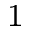<formula> <loc_0><loc_0><loc_500><loc_500>^ { 1 }</formula> 